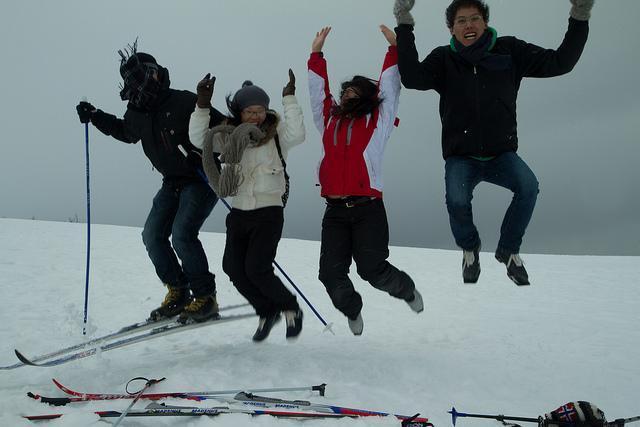How many people are there?
Give a very brief answer. 4. 